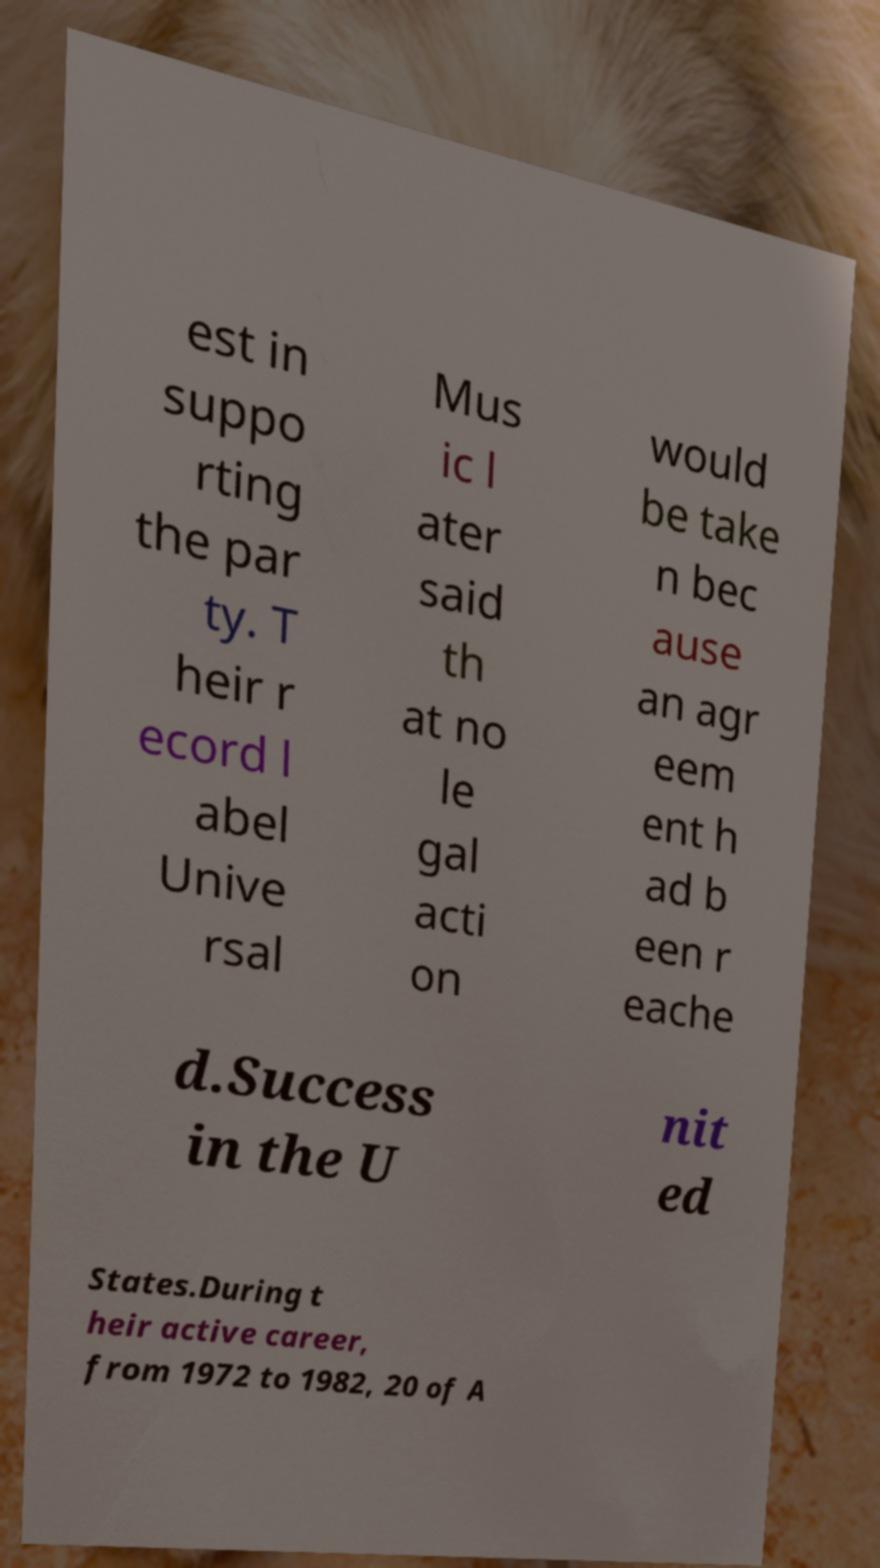I need the written content from this picture converted into text. Can you do that? est in suppo rting the par ty. T heir r ecord l abel Unive rsal Mus ic l ater said th at no le gal acti on would be take n bec ause an agr eem ent h ad b een r eache d.Success in the U nit ed States.During t heir active career, from 1972 to 1982, 20 of A 